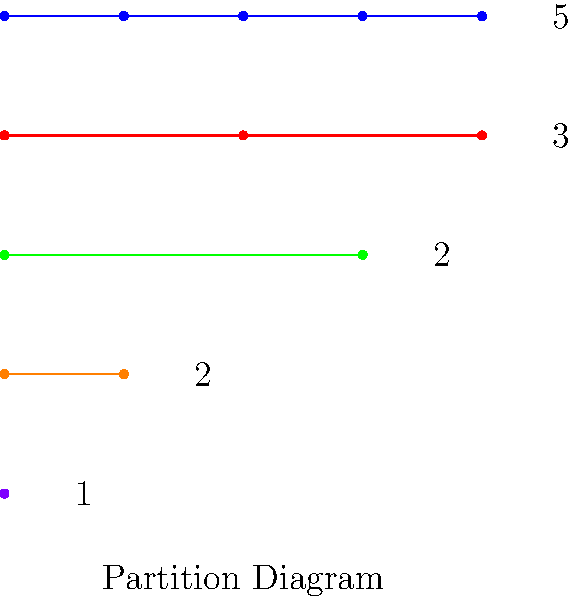As a project manager overseeing a cloud migration, you're tasked with optimizing resource allocation based on group theory principles. Given the partition diagram above representing the cycle structure of permutations in a symmetric group $S_n$, determine the number of conjugacy classes in this group. How does this relate to the number of distinct ways to partition the integer $n$? To solve this problem, we'll follow these steps:

1. Understand the partition diagram:
   - Each row represents a partition of an integer.
   - The number of dots in each row indicates the length of each part in the partition.
   - The label on the right shows how many times that part appears in the partition.

2. Interpret the diagram:
   - We see partitions: [5], [3,1,1], [2,2,1], [2,1,1,1], and [1,1,1,1,1]
   - This represents all possible ways to partition the integer 5

3. Recall the relationship between partitions and conjugacy classes:
   - In the symmetric group $S_n$, conjugacy classes correspond one-to-one with partitions of $n$.
   - Each partition represents a cycle type of permutations.

4. Count the number of partitions:
   - There are 5 distinct partitions shown in the diagram.

5. Conclude:
   - The number of conjugacy classes in $S_5$ is equal to the number of partitions of 5, which is 7.

6. Relate to cloud migration:
   - In cloud resource allocation, understanding group structures can help in optimizing task distribution and load balancing across different server configurations.
Answer: 7 conjugacy classes, equal to the number of partitions of 5 